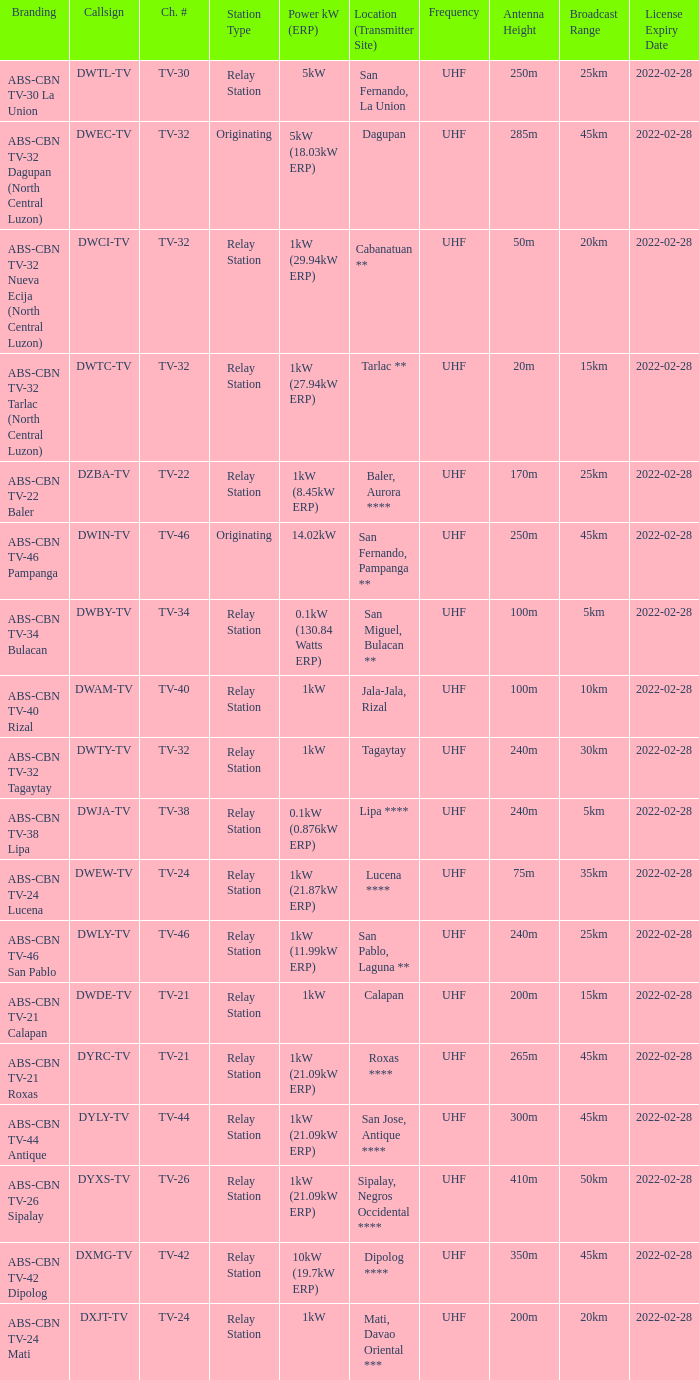The location (transmitter site) San Fernando, Pampanga ** has what Power kW (ERP)? 14.02kW. 